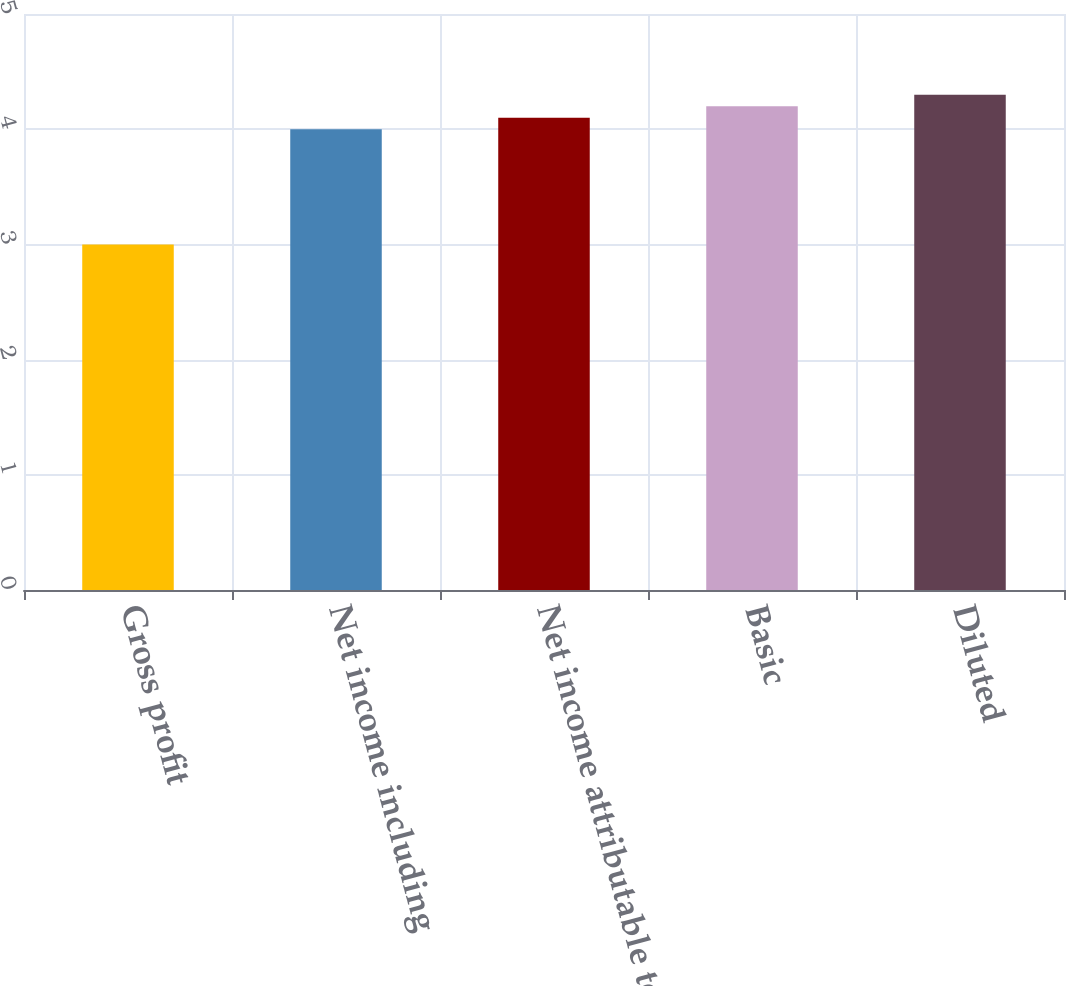Convert chart to OTSL. <chart><loc_0><loc_0><loc_500><loc_500><bar_chart><fcel>Gross profit<fcel>Net income including<fcel>Net income attributable to<fcel>Basic<fcel>Diluted<nl><fcel>3<fcel>4<fcel>4.1<fcel>4.2<fcel>4.3<nl></chart> 